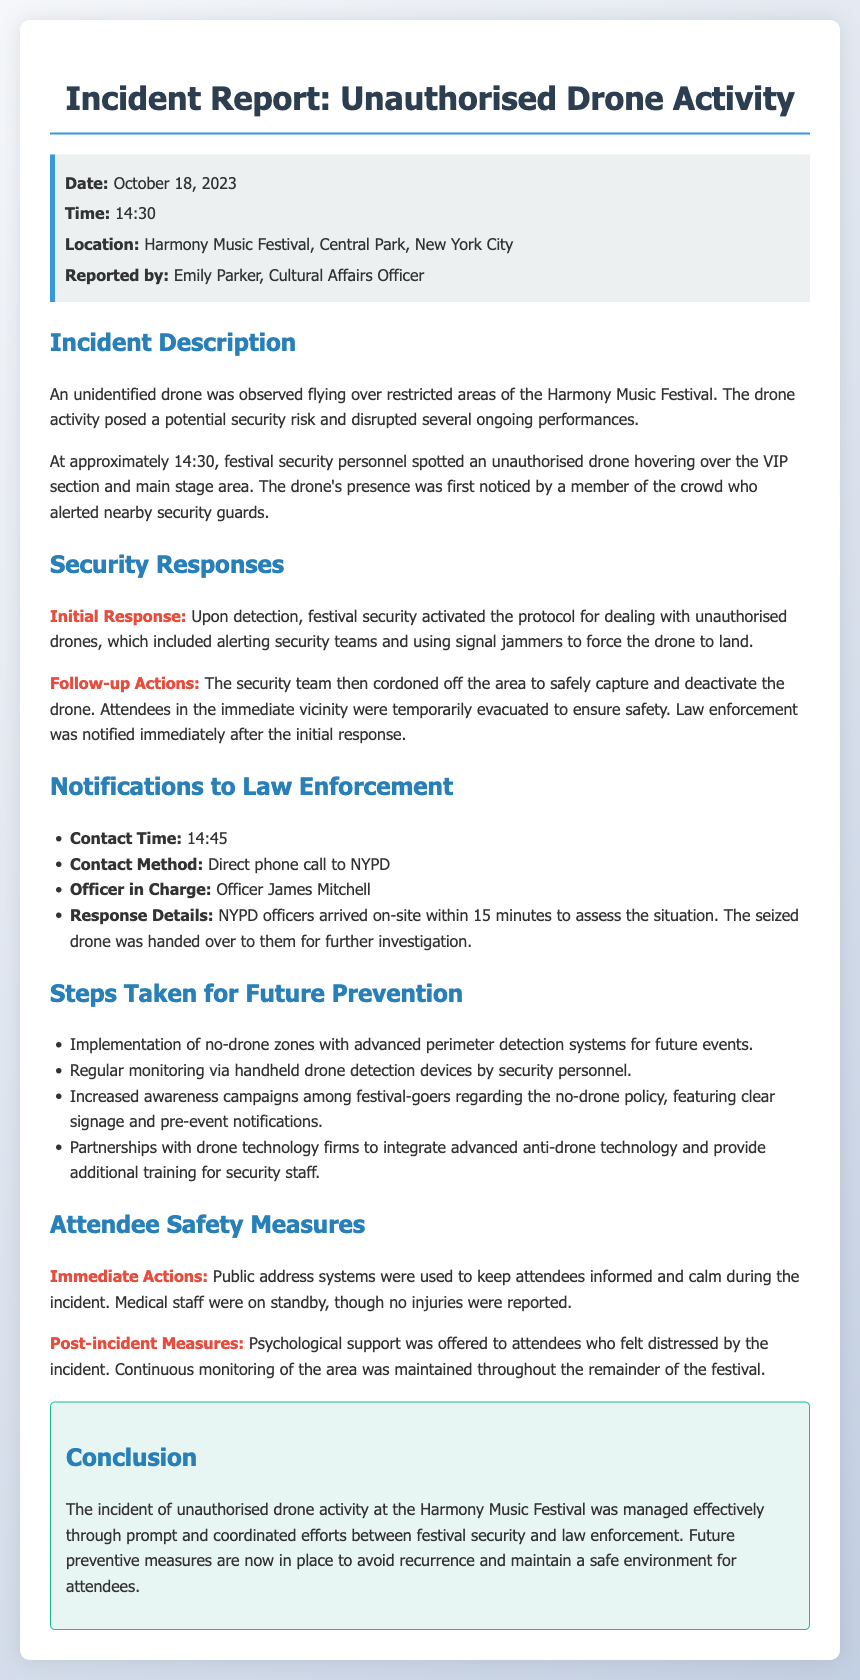What was the date of the incident? The date of the incident is mentioned in the document as October 18, 2023.
Answer: October 18, 2023 What time did the drone activity occur? The time of the drone activity is specified as 14:30 in the incident report.
Answer: 14:30 Who reported the incident? The document indicates that the incident was reported by Emily Parker.
Answer: Emily Parker What area was the drone observed hovering over? The report states that the drone was hovering over the VIP section and main stage area.
Answer: VIP section and main stage area What was the initial response of festival security? The document details that festival security activated the protocol for dealing with unauthorised drones.
Answer: Activated the protocol How long did it take for NYPD officers to arrive on-site? The report informs that NYPD officers arrived on-site within 15 minutes of contact.
Answer: 15 minutes What safety measure was implemented for future events regarding drone activity? The document mentions the implementation of no-drone zones with advanced perimeter detection systems.
Answer: No-drone zones What was offered to attendees post-incident? The report states that psychological support was offered to attendees who felt distressed.
Answer: Psychological support 